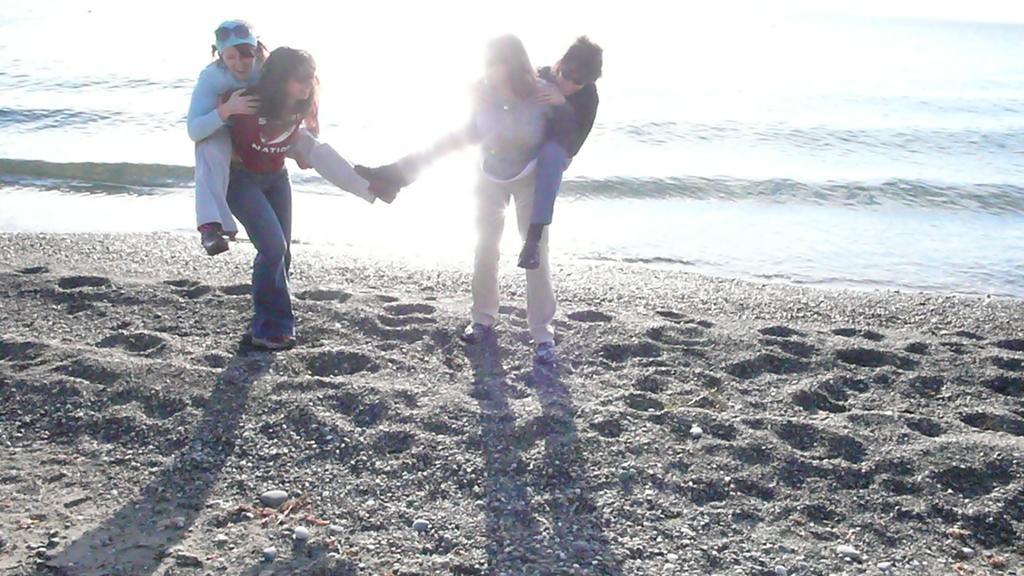Could you give a brief overview of what you see in this image? In this picture there are people and we can see water, sand and stones. 